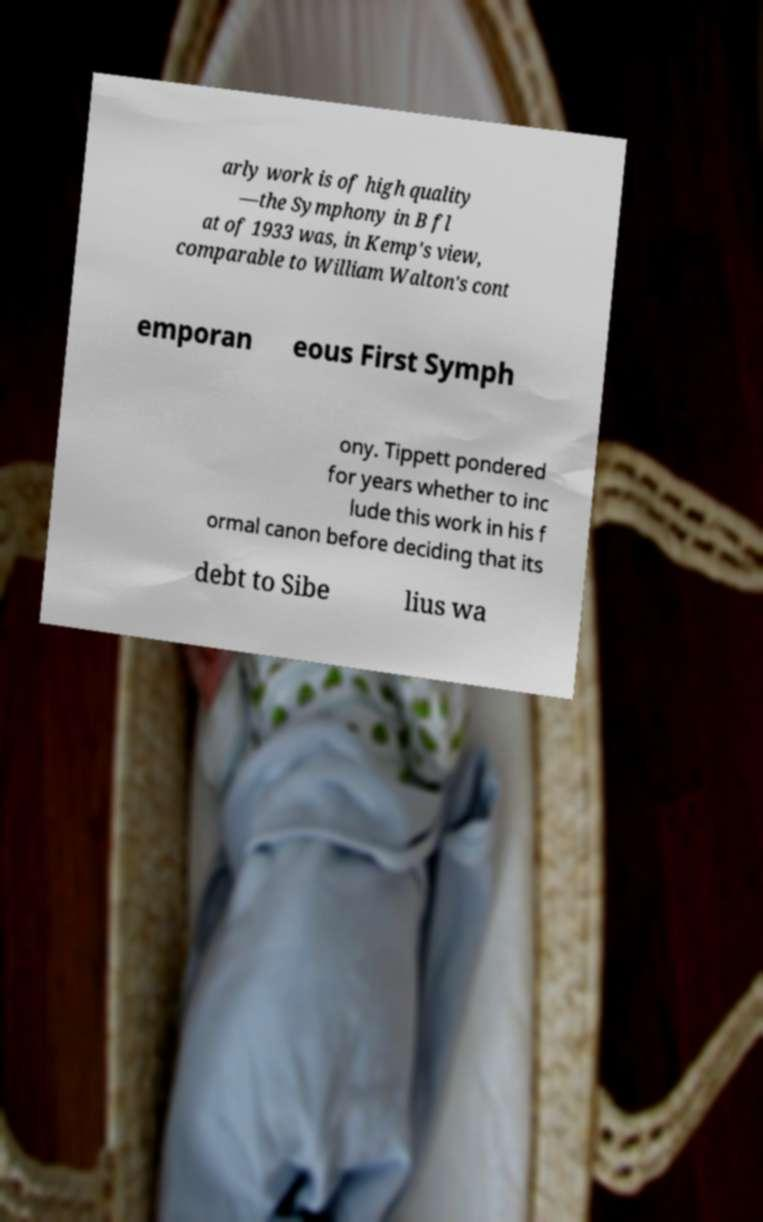For documentation purposes, I need the text within this image transcribed. Could you provide that? arly work is of high quality —the Symphony in B fl at of 1933 was, in Kemp's view, comparable to William Walton's cont emporan eous First Symph ony. Tippett pondered for years whether to inc lude this work in his f ormal canon before deciding that its debt to Sibe lius wa 